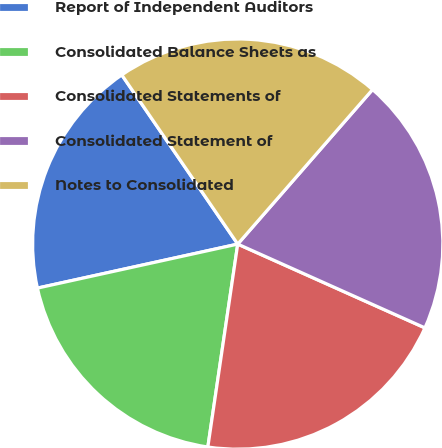Convert chart to OTSL. <chart><loc_0><loc_0><loc_500><loc_500><pie_chart><fcel>Report of Independent Auditors<fcel>Consolidated Balance Sheets as<fcel>Consolidated Statements of<fcel>Consolidated Statement of<fcel>Notes to Consolidated<nl><fcel>18.88%<fcel>19.23%<fcel>20.63%<fcel>20.28%<fcel>20.98%<nl></chart> 